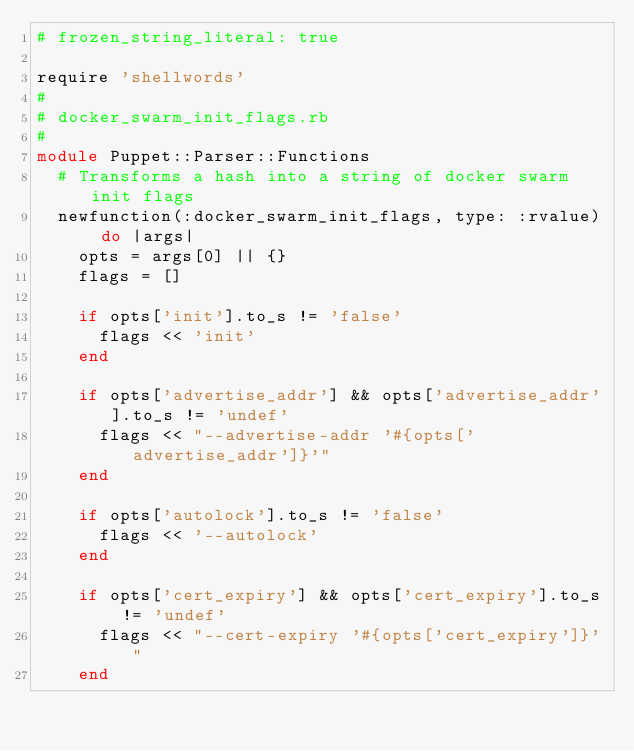Convert code to text. <code><loc_0><loc_0><loc_500><loc_500><_Ruby_># frozen_string_literal: true

require 'shellwords'
#
# docker_swarm_init_flags.rb
#
module Puppet::Parser::Functions
  # Transforms a hash into a string of docker swarm init flags
  newfunction(:docker_swarm_init_flags, type: :rvalue) do |args|
    opts = args[0] || {}
    flags = []

    if opts['init'].to_s != 'false'
      flags << 'init'
    end

    if opts['advertise_addr'] && opts['advertise_addr'].to_s != 'undef'
      flags << "--advertise-addr '#{opts['advertise_addr']}'"
    end

    if opts['autolock'].to_s != 'false'
      flags << '--autolock'
    end

    if opts['cert_expiry'] && opts['cert_expiry'].to_s != 'undef'
      flags << "--cert-expiry '#{opts['cert_expiry']}'"
    end
</code> 